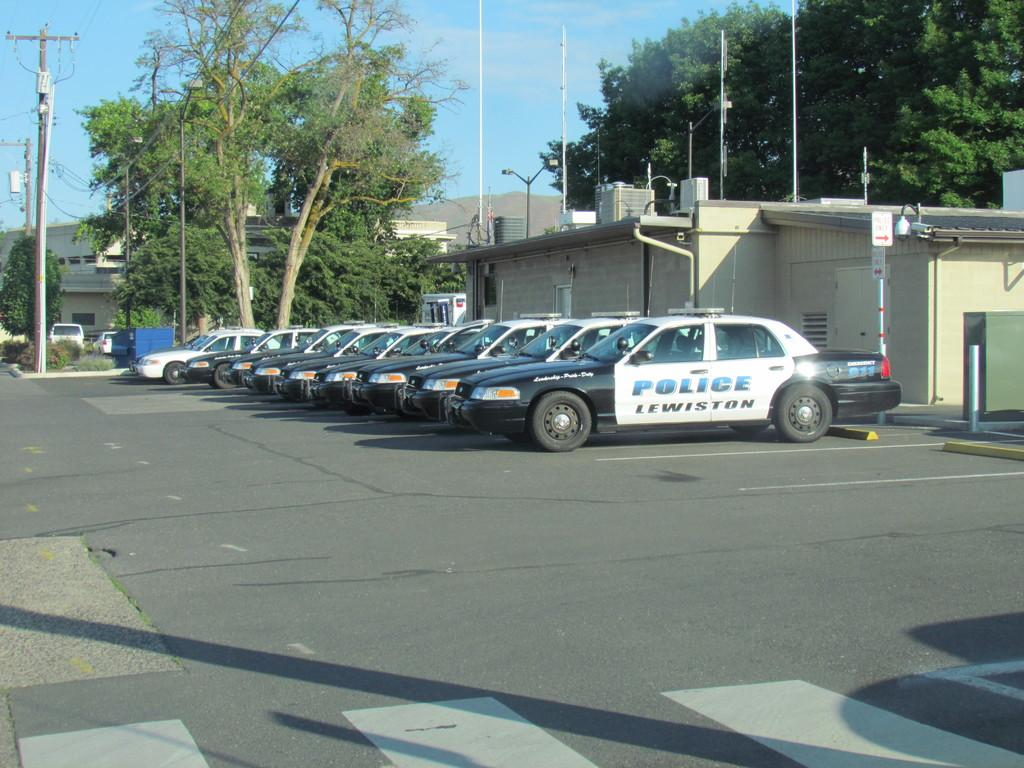What is present on the road in the image? There are vehicles on the road in the image. What can be seen in the background of the image? There are trees, buildings, and poles in the background of the image. What is connected to the poles in the background? There are wires associated with the poles in the background of the image. Can you see a monkey climbing the sheet hanging from the fire in the image? There is no monkey, sheet, or fire present in the image. 